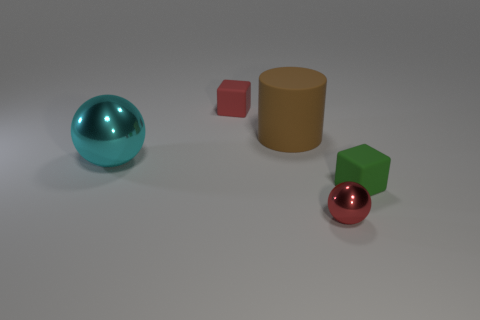Is the material of the tiny green cube the same as the big cyan object?
Your answer should be very brief. No. How many other things are the same shape as the green object?
Your answer should be compact. 1. How big is the thing that is both behind the small red shiny sphere and on the right side of the brown thing?
Your response must be concise. Small. How many matte things are either small cyan blocks or cylinders?
Provide a short and direct response. 1. There is a rubber object on the right side of the big brown rubber object; does it have the same shape as the small matte object that is on the left side of the red metallic object?
Your answer should be compact. Yes. Are there any brown things made of the same material as the green thing?
Your answer should be compact. Yes. The large cylinder is what color?
Make the answer very short. Brown. There is a cyan sphere that is on the left side of the small green object; what size is it?
Give a very brief answer. Large. What number of small matte things are the same color as the tiny sphere?
Keep it short and to the point. 1. There is a tiny red object behind the small green thing; is there a thing right of it?
Your answer should be very brief. Yes. 